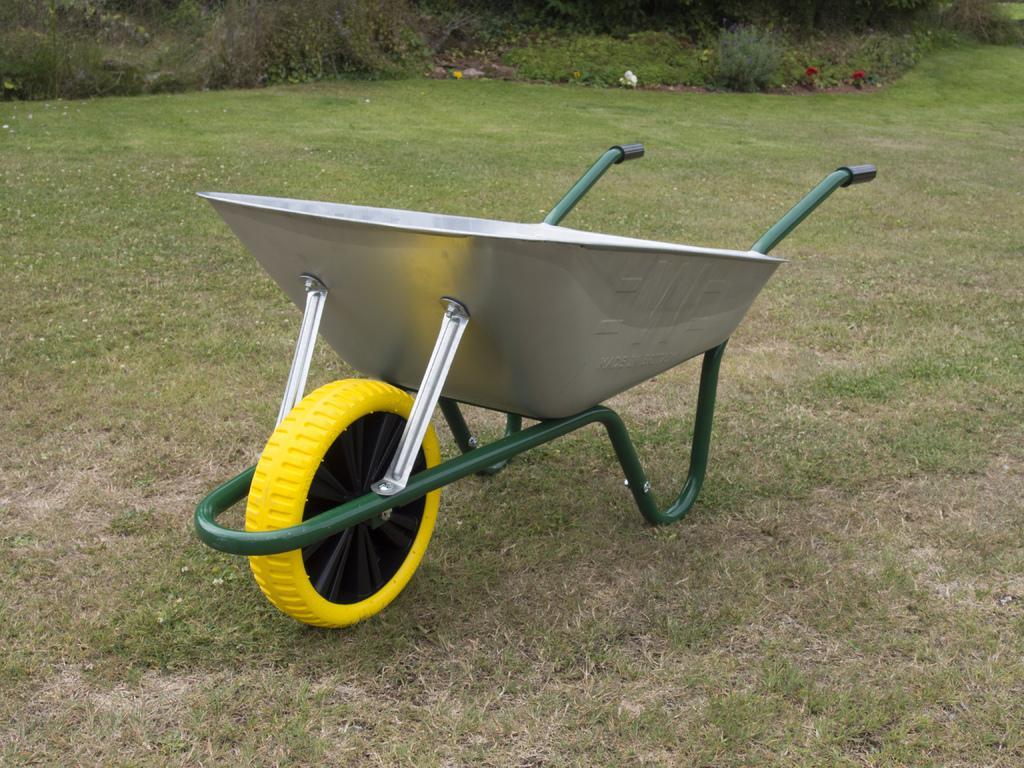What is the main object in the image? There is a trolley in the image. What colors can be seen on the trolley? The trolley has silver, yellow, black, and green colors. What type of vegetation is visible in the image? There is green grass in the image. What can be seen in the background of the image? There are plants in the background of the image. Are there any cobwebs visible on the trolley in the image? There is no mention of cobwebs in the provided facts, and therefore we cannot determine if any are present in the image. 